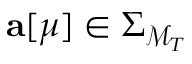<formula> <loc_0><loc_0><loc_500><loc_500>{ a } [ \mu ] \in \Sigma _ { \mathcal { M } _ { T } }</formula> 